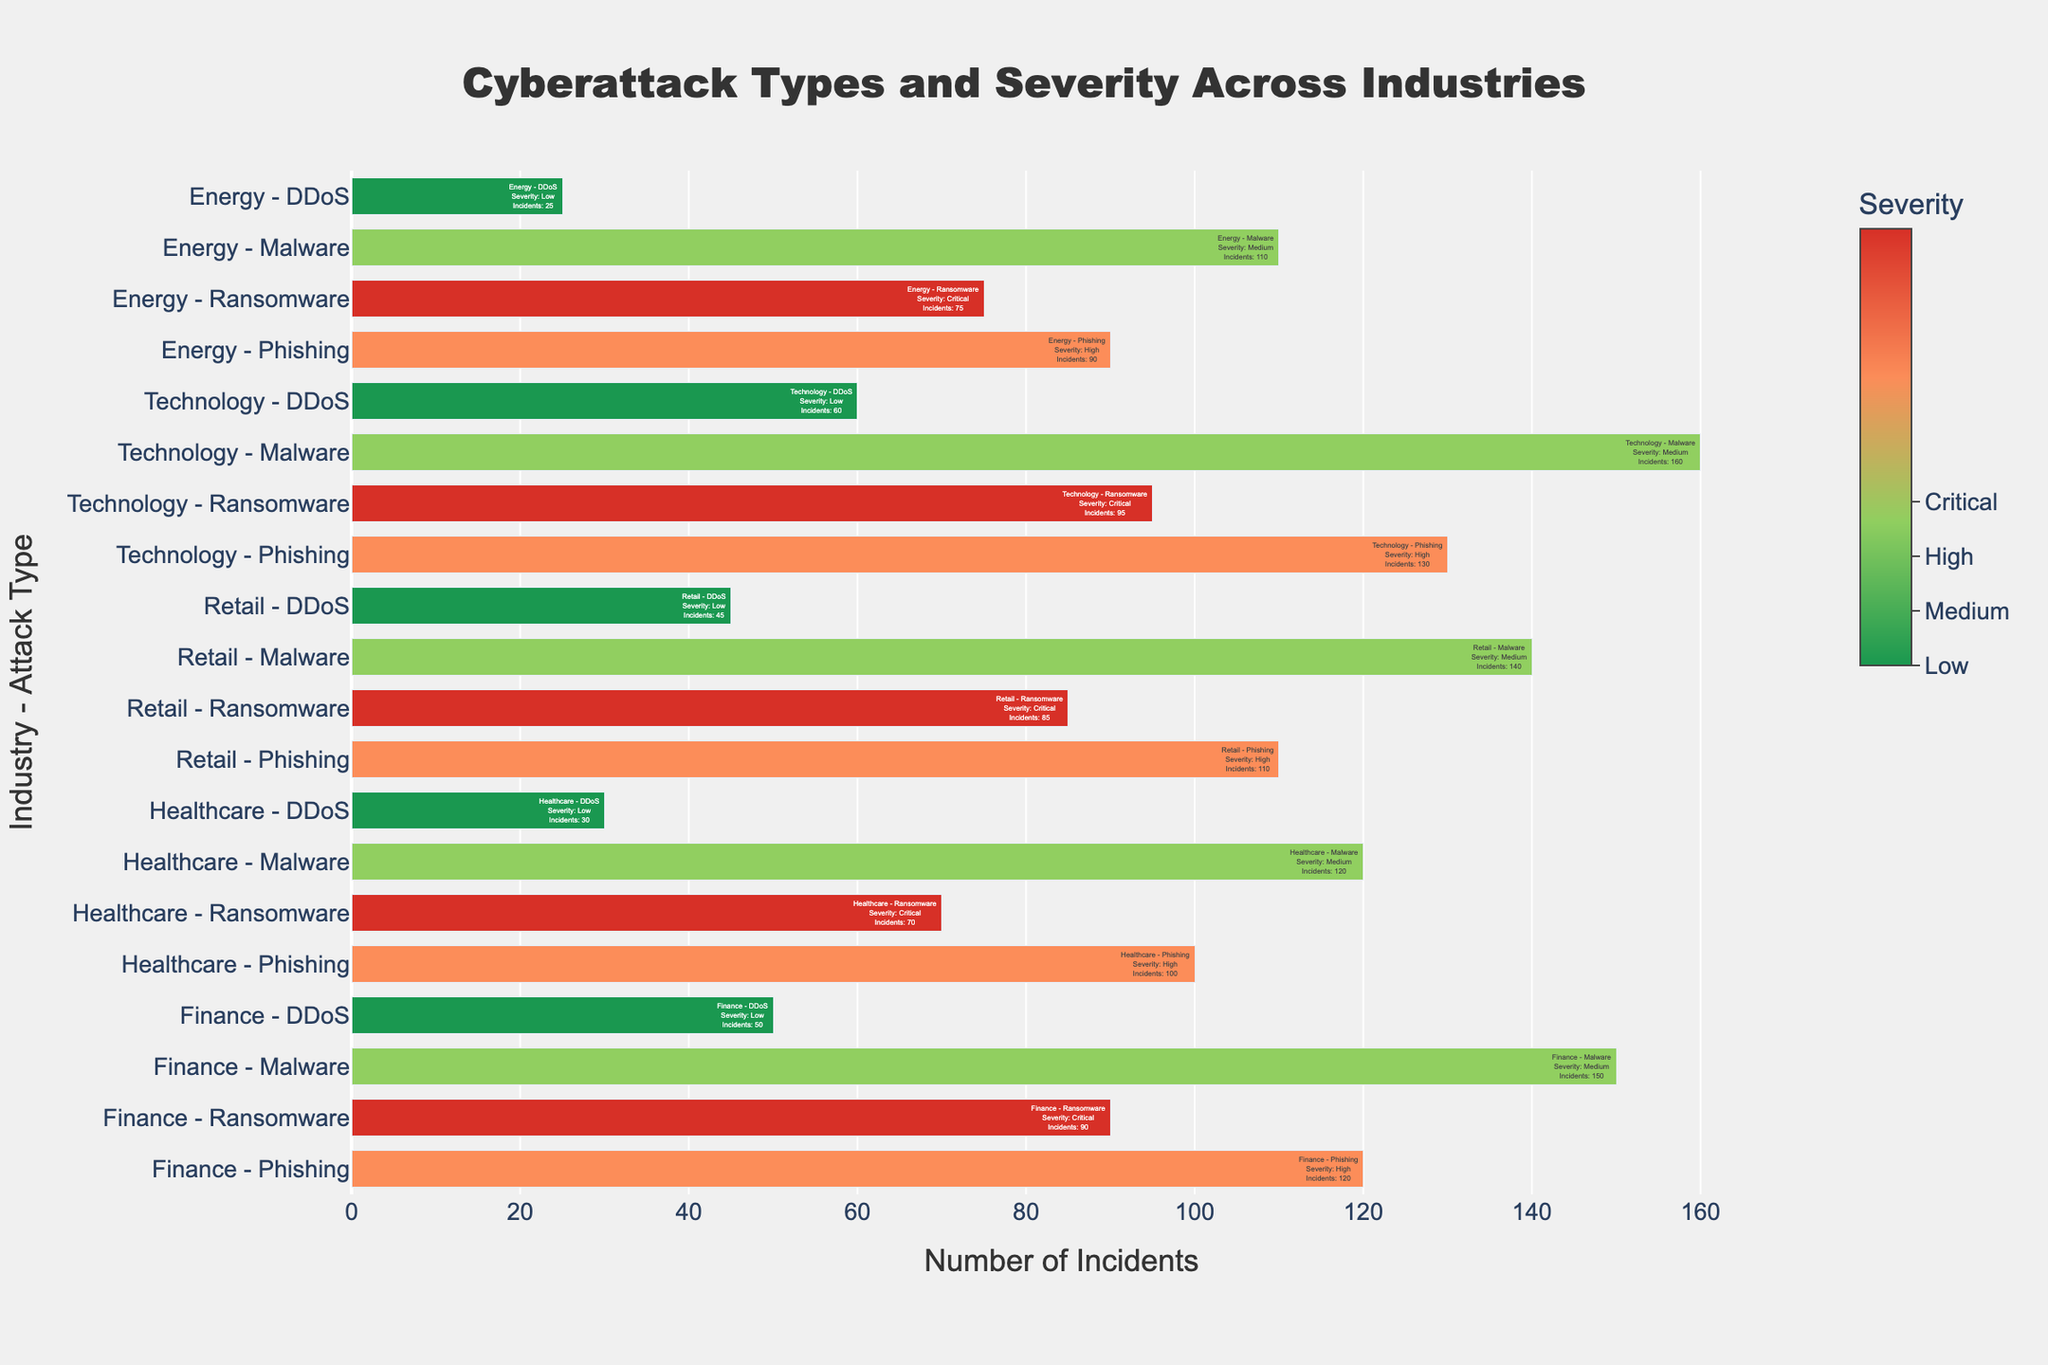Which industry has the highest number of incidents for Ransomware attacks? Find the bar representing the industry with the highest value for Ransomware (Critical severity). By comparing the lengths of the bars for Ransomware across all industries, we can see that Technology has the longest bar representing 95 incidents.
Answer: Technology Which industry experienced the least number of DDoS incidents? Look at the bars assigned to DDoS attacks (Low severity). The shortest bar corresponds to the Energy industry, indicating 25 incidents.
Answer: Energy In the Finance industry, how many more incidents were there for Malware compared to DDoS? In the Finance industry, Malware (Medium severity) incidents are 150, while DDoS (Low severity) incidents are 50. The difference is 150 - 50 = 100.
Answer: 100 What is the total number of incidents across all industries for Phishing attacks? Summing the number of incidents for Phishing (High severity) across all industries: Finance (120) + Healthcare (100) + Retail (110) + Technology (130) + Energy (90) equals 550.
Answer: 550 Which attack type in the Healthcare industry has the fewest incidents? By comparing the bars for different attack types in Healthcare, DDoS (Low severity) has the shortest bar with 30 incidents.
Answer: DDoS What is the total number of Ransomware incidents across all industries? Summing the Ransomware (Critical severity) incidents: Finance (90) + Healthcare (70) + Retail (85) + Technology (95) + Energy (75) equals 415.
Answer: 415 Which industry has a higher number of incidents for Malware, Retail or Energy? Comparing the Malware (Medium severity) bars for Retail and Energy, Retail has 140 incidents while Energy has 110. Retail has more incidents.
Answer: Retail How many total incidents are there for the Technology industry? Summing the incidents for all attack types in Technology: Phishing (130) + Ransomware (95) + Malware (160) + DDoS (60) equals 445.
Answer: 445 Which severity level in the Retail industry has the highest number of incidents? By comparing the bar lengths for each severity level in the Retail industry, Malware (Medium severity) has the highest number with 140 incidents.
Answer: Medium What is the average number of incidents for Phishing attacks across all industries? Summing the incidents for Phishing (High severity) across all industries and then dividing by the number of industries: (120 + 100 + 110 + 130 + 90) / 5 equals 110.
Answer: 110 